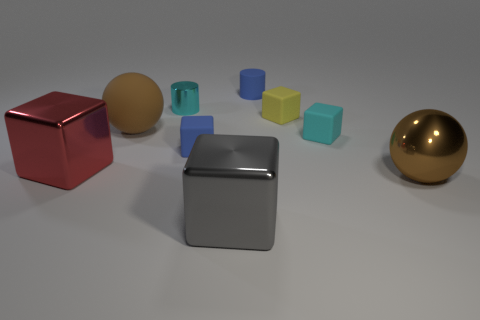Subtract all red shiny blocks. How many blocks are left? 4 Add 1 tiny yellow metallic objects. How many objects exist? 10 Subtract all gray blocks. How many blocks are left? 4 Subtract all blocks. How many objects are left? 4 Subtract 1 spheres. How many spheres are left? 1 Subtract all big cylinders. Subtract all large gray blocks. How many objects are left? 8 Add 1 big brown rubber spheres. How many big brown rubber spheres are left? 2 Add 4 brown matte balls. How many brown matte balls exist? 5 Subtract 1 cyan cylinders. How many objects are left? 8 Subtract all brown blocks. Subtract all green balls. How many blocks are left? 5 